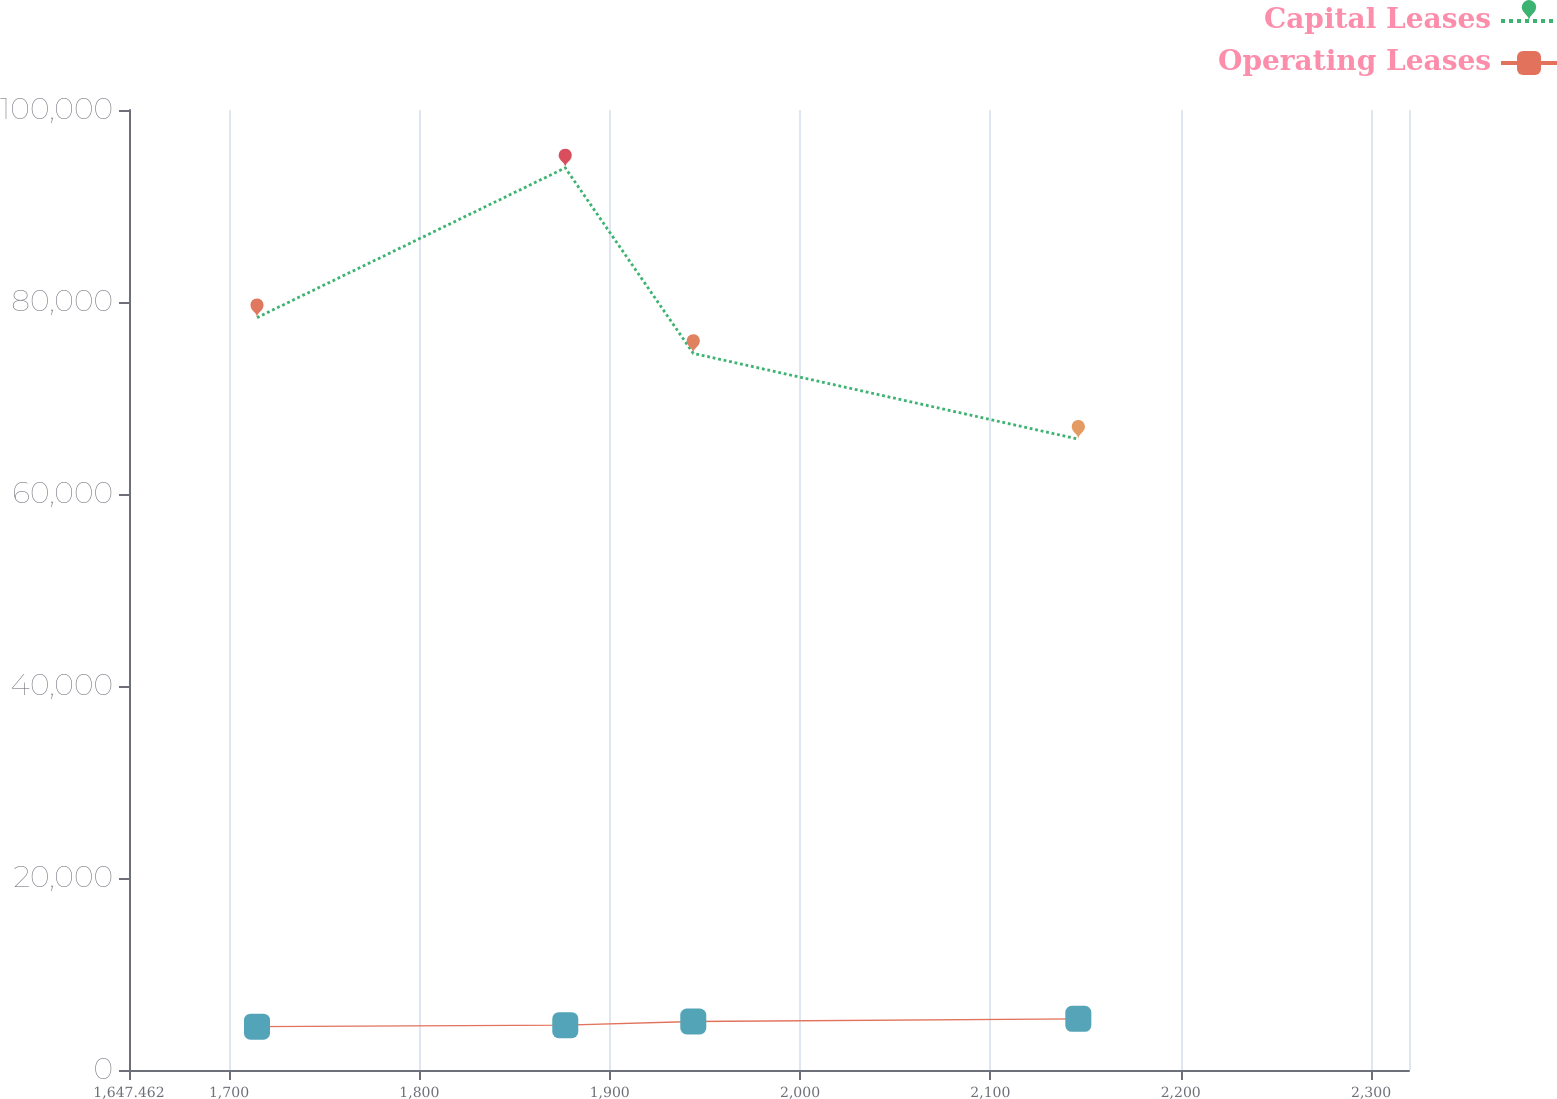<chart> <loc_0><loc_0><loc_500><loc_500><line_chart><ecel><fcel>Capital Leases<fcel>Operating Leases<nl><fcel>1714.71<fcel>78372.8<fcel>4513.39<nl><fcel>1876.67<fcel>93973.1<fcel>4672.18<nl><fcel>1943.92<fcel>74647.9<fcel>5049.3<nl><fcel>2146.21<fcel>65715.3<fcel>5330.35<nl><fcel>2387.19<fcel>68541.1<fcel>3742.5<nl></chart> 